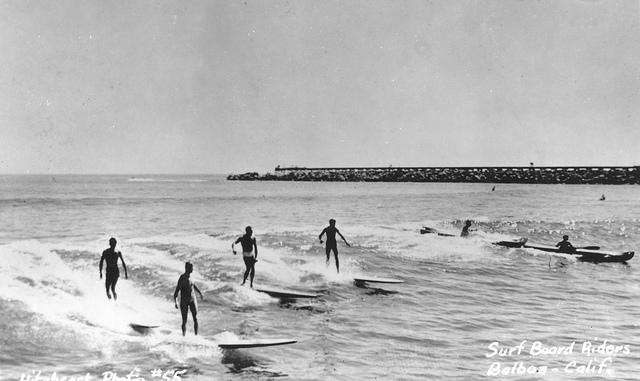Is this a picture of a modern scene?
Answer briefly. No. Is this a calendar shoot?
Write a very short answer. No. Is everyone accounted for?
Write a very short answer. Yes. 